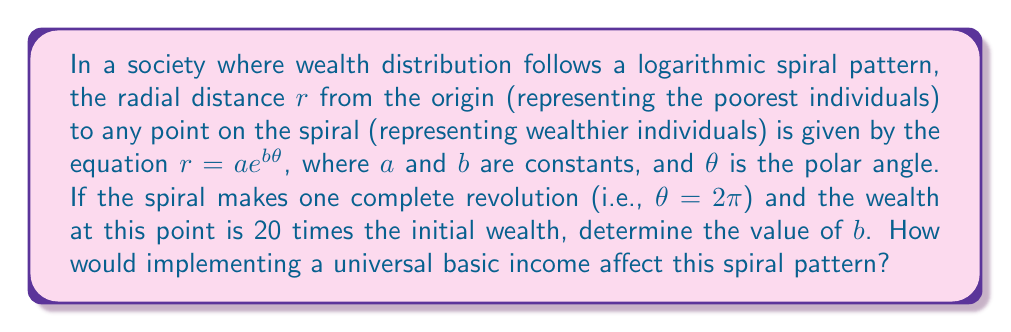Help me with this question. To solve this problem, we need to follow these steps:

1) The equation of the logarithmic spiral is given as:

   $r = ae^{b\theta}$

2) We're told that after one complete revolution ($\theta = 2\pi$), the wealth is 20 times the initial wealth. This means:

   $\frac{r(\theta = 2\pi)}{r(\theta = 0)} = 20$

3) Let's substitute these values into the equation:

   $\frac{ae^{b(2\pi)}}{ae^{b(0)}} = 20$

4) Simplify:

   $\frac{ae^{2\pi b}}{a} = 20$

5) The $a$ cancels out:

   $e^{2\pi b} = 20$

6) Take the natural log of both sides:

   $\ln(e^{2\pi b}) = \ln(20)$

7) Simplify:

   $2\pi b = \ln(20)$

8) Solve for $b$:

   $b = \frac{\ln(20)}{2\pi}$

9) Calculate the value:

   $b \approx 0.4866$

Regarding the impact of universal basic income (UBI):

Implementing a UBI would likely flatten the spiral pattern. It would increase the initial radius (representing the wealth of the poorest individuals) and potentially decrease the rate at which the spiral expands (reducing the value of $b$). This would result in a less extreme wealth distribution, visually represented by a more gradual and wider spiral.
Answer: $b \approx 0.4866$

Implementing a universal basic income would likely flatten the spiral pattern, increasing the initial radius and potentially decreasing the value of $b$, resulting in a more gradual wealth distribution curve. 